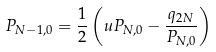<formula> <loc_0><loc_0><loc_500><loc_500>P _ { N - 1 , 0 } = \frac { 1 } { 2 } \left ( u P _ { N , 0 } - \frac { q _ { 2 N } } { P _ { N , 0 } } \right )</formula> 